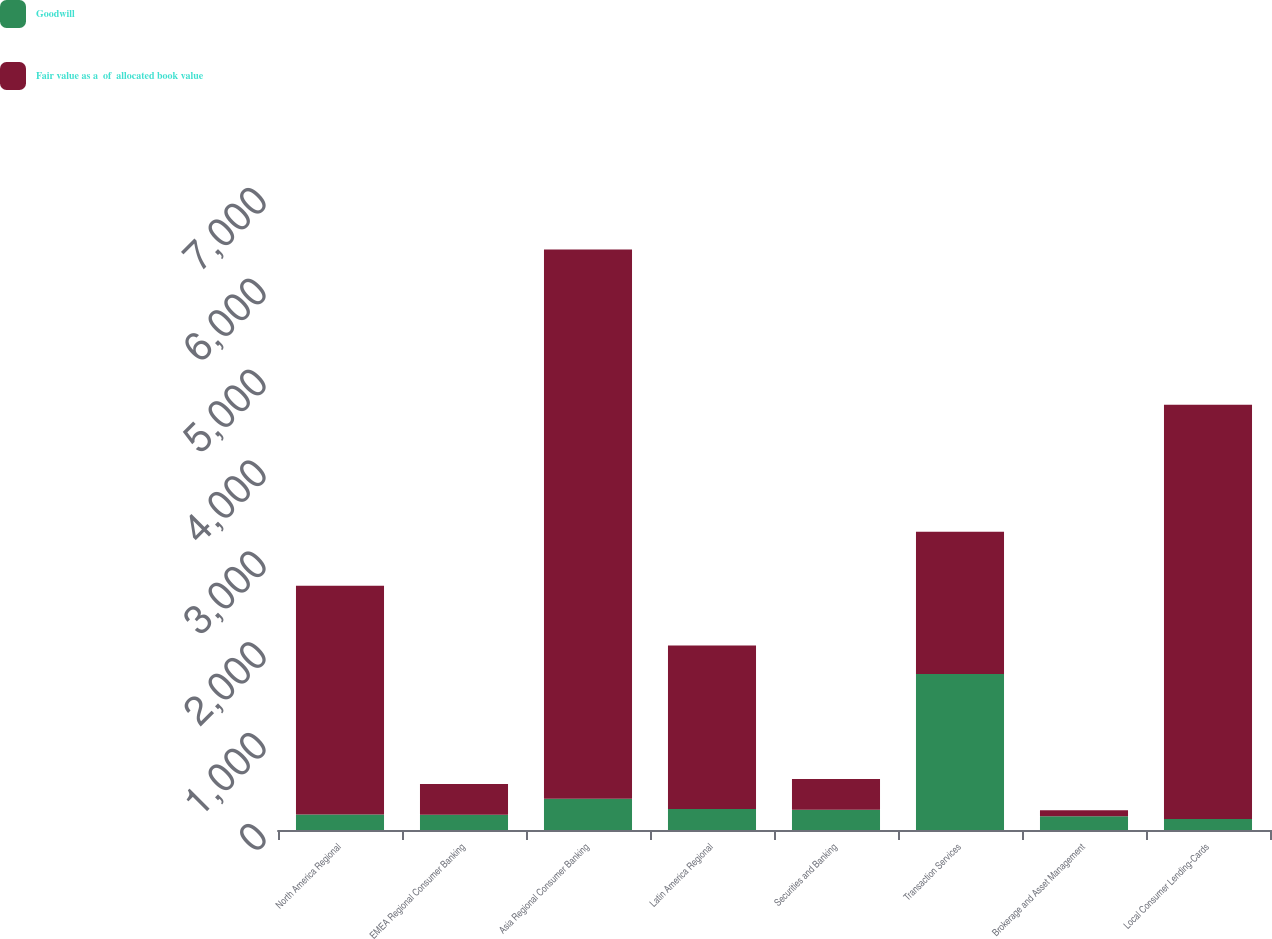Convert chart to OTSL. <chart><loc_0><loc_0><loc_500><loc_500><stacked_bar_chart><ecel><fcel>North America Regional<fcel>EMEA Regional Consumer Banking<fcel>Asia Regional Consumer Banking<fcel>Latin America Regional<fcel>Securities and Banking<fcel>Transaction Services<fcel>Brokerage and Asset Management<fcel>Local Consumer Lending-Cards<nl><fcel>Goodwill<fcel>170<fcel>168<fcel>344<fcel>230<fcel>223<fcel>1716<fcel>151<fcel>121<nl><fcel>Fair value as a  of  allocated book value<fcel>2518<fcel>338<fcel>6045<fcel>1800<fcel>338<fcel>1567<fcel>65<fcel>4560<nl></chart> 